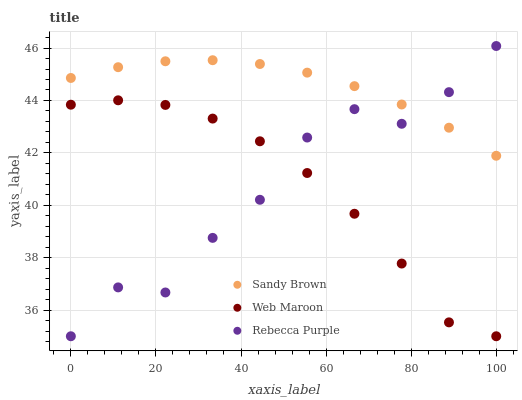Does Rebecca Purple have the minimum area under the curve?
Answer yes or no. Yes. Does Sandy Brown have the maximum area under the curve?
Answer yes or no. Yes. Does Sandy Brown have the minimum area under the curve?
Answer yes or no. No. Does Rebecca Purple have the maximum area under the curve?
Answer yes or no. No. Is Sandy Brown the smoothest?
Answer yes or no. Yes. Is Rebecca Purple the roughest?
Answer yes or no. Yes. Is Rebecca Purple the smoothest?
Answer yes or no. No. Is Sandy Brown the roughest?
Answer yes or no. No. Does Web Maroon have the lowest value?
Answer yes or no. Yes. Does Sandy Brown have the lowest value?
Answer yes or no. No. Does Rebecca Purple have the highest value?
Answer yes or no. Yes. Does Sandy Brown have the highest value?
Answer yes or no. No. Is Web Maroon less than Sandy Brown?
Answer yes or no. Yes. Is Sandy Brown greater than Web Maroon?
Answer yes or no. Yes. Does Rebecca Purple intersect Web Maroon?
Answer yes or no. Yes. Is Rebecca Purple less than Web Maroon?
Answer yes or no. No. Is Rebecca Purple greater than Web Maroon?
Answer yes or no. No. Does Web Maroon intersect Sandy Brown?
Answer yes or no. No. 